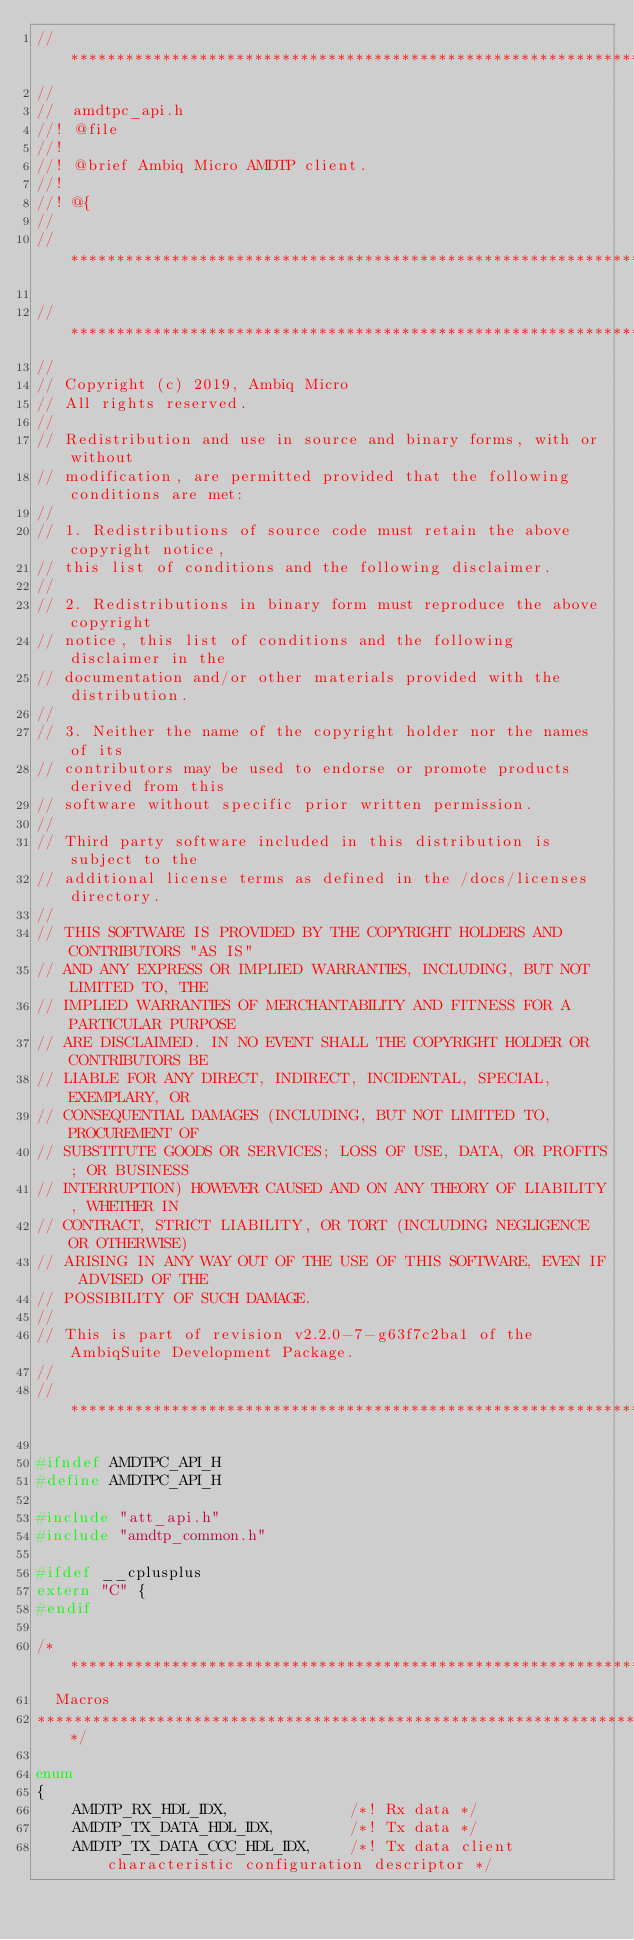<code> <loc_0><loc_0><loc_500><loc_500><_C_>// ****************************************************************************
//
//  amdtpc_api.h
//! @file
//!
//! @brief Ambiq Micro AMDTP client.
//!
//! @{
//
// ****************************************************************************

//*****************************************************************************
//
// Copyright (c) 2019, Ambiq Micro
// All rights reserved.
// 
// Redistribution and use in source and binary forms, with or without
// modification, are permitted provided that the following conditions are met:
// 
// 1. Redistributions of source code must retain the above copyright notice,
// this list of conditions and the following disclaimer.
// 
// 2. Redistributions in binary form must reproduce the above copyright
// notice, this list of conditions and the following disclaimer in the
// documentation and/or other materials provided with the distribution.
// 
// 3. Neither the name of the copyright holder nor the names of its
// contributors may be used to endorse or promote products derived from this
// software without specific prior written permission.
// 
// Third party software included in this distribution is subject to the
// additional license terms as defined in the /docs/licenses directory.
// 
// THIS SOFTWARE IS PROVIDED BY THE COPYRIGHT HOLDERS AND CONTRIBUTORS "AS IS"
// AND ANY EXPRESS OR IMPLIED WARRANTIES, INCLUDING, BUT NOT LIMITED TO, THE
// IMPLIED WARRANTIES OF MERCHANTABILITY AND FITNESS FOR A PARTICULAR PURPOSE
// ARE DISCLAIMED. IN NO EVENT SHALL THE COPYRIGHT HOLDER OR CONTRIBUTORS BE
// LIABLE FOR ANY DIRECT, INDIRECT, INCIDENTAL, SPECIAL, EXEMPLARY, OR
// CONSEQUENTIAL DAMAGES (INCLUDING, BUT NOT LIMITED TO, PROCUREMENT OF
// SUBSTITUTE GOODS OR SERVICES; LOSS OF USE, DATA, OR PROFITS; OR BUSINESS
// INTERRUPTION) HOWEVER CAUSED AND ON ANY THEORY OF LIABILITY, WHETHER IN
// CONTRACT, STRICT LIABILITY, OR TORT (INCLUDING NEGLIGENCE OR OTHERWISE)
// ARISING IN ANY WAY OUT OF THE USE OF THIS SOFTWARE, EVEN IF ADVISED OF THE
// POSSIBILITY OF SUCH DAMAGE.
//
// This is part of revision v2.2.0-7-g63f7c2ba1 of the AmbiqSuite Development Package.
//
//*****************************************************************************

#ifndef AMDTPC_API_H
#define AMDTPC_API_H

#include "att_api.h"
#include "amdtp_common.h"

#ifdef __cplusplus
extern "C" {
#endif

/**************************************************************************************************
  Macros
**************************************************************************************************/

enum
{
    AMDTP_RX_HDL_IDX,             /*! Rx data */
    AMDTP_TX_DATA_HDL_IDX,        /*! Tx data */
    AMDTP_TX_DATA_CCC_HDL_IDX,    /*! Tx data client characteristic configuration descriptor */</code> 